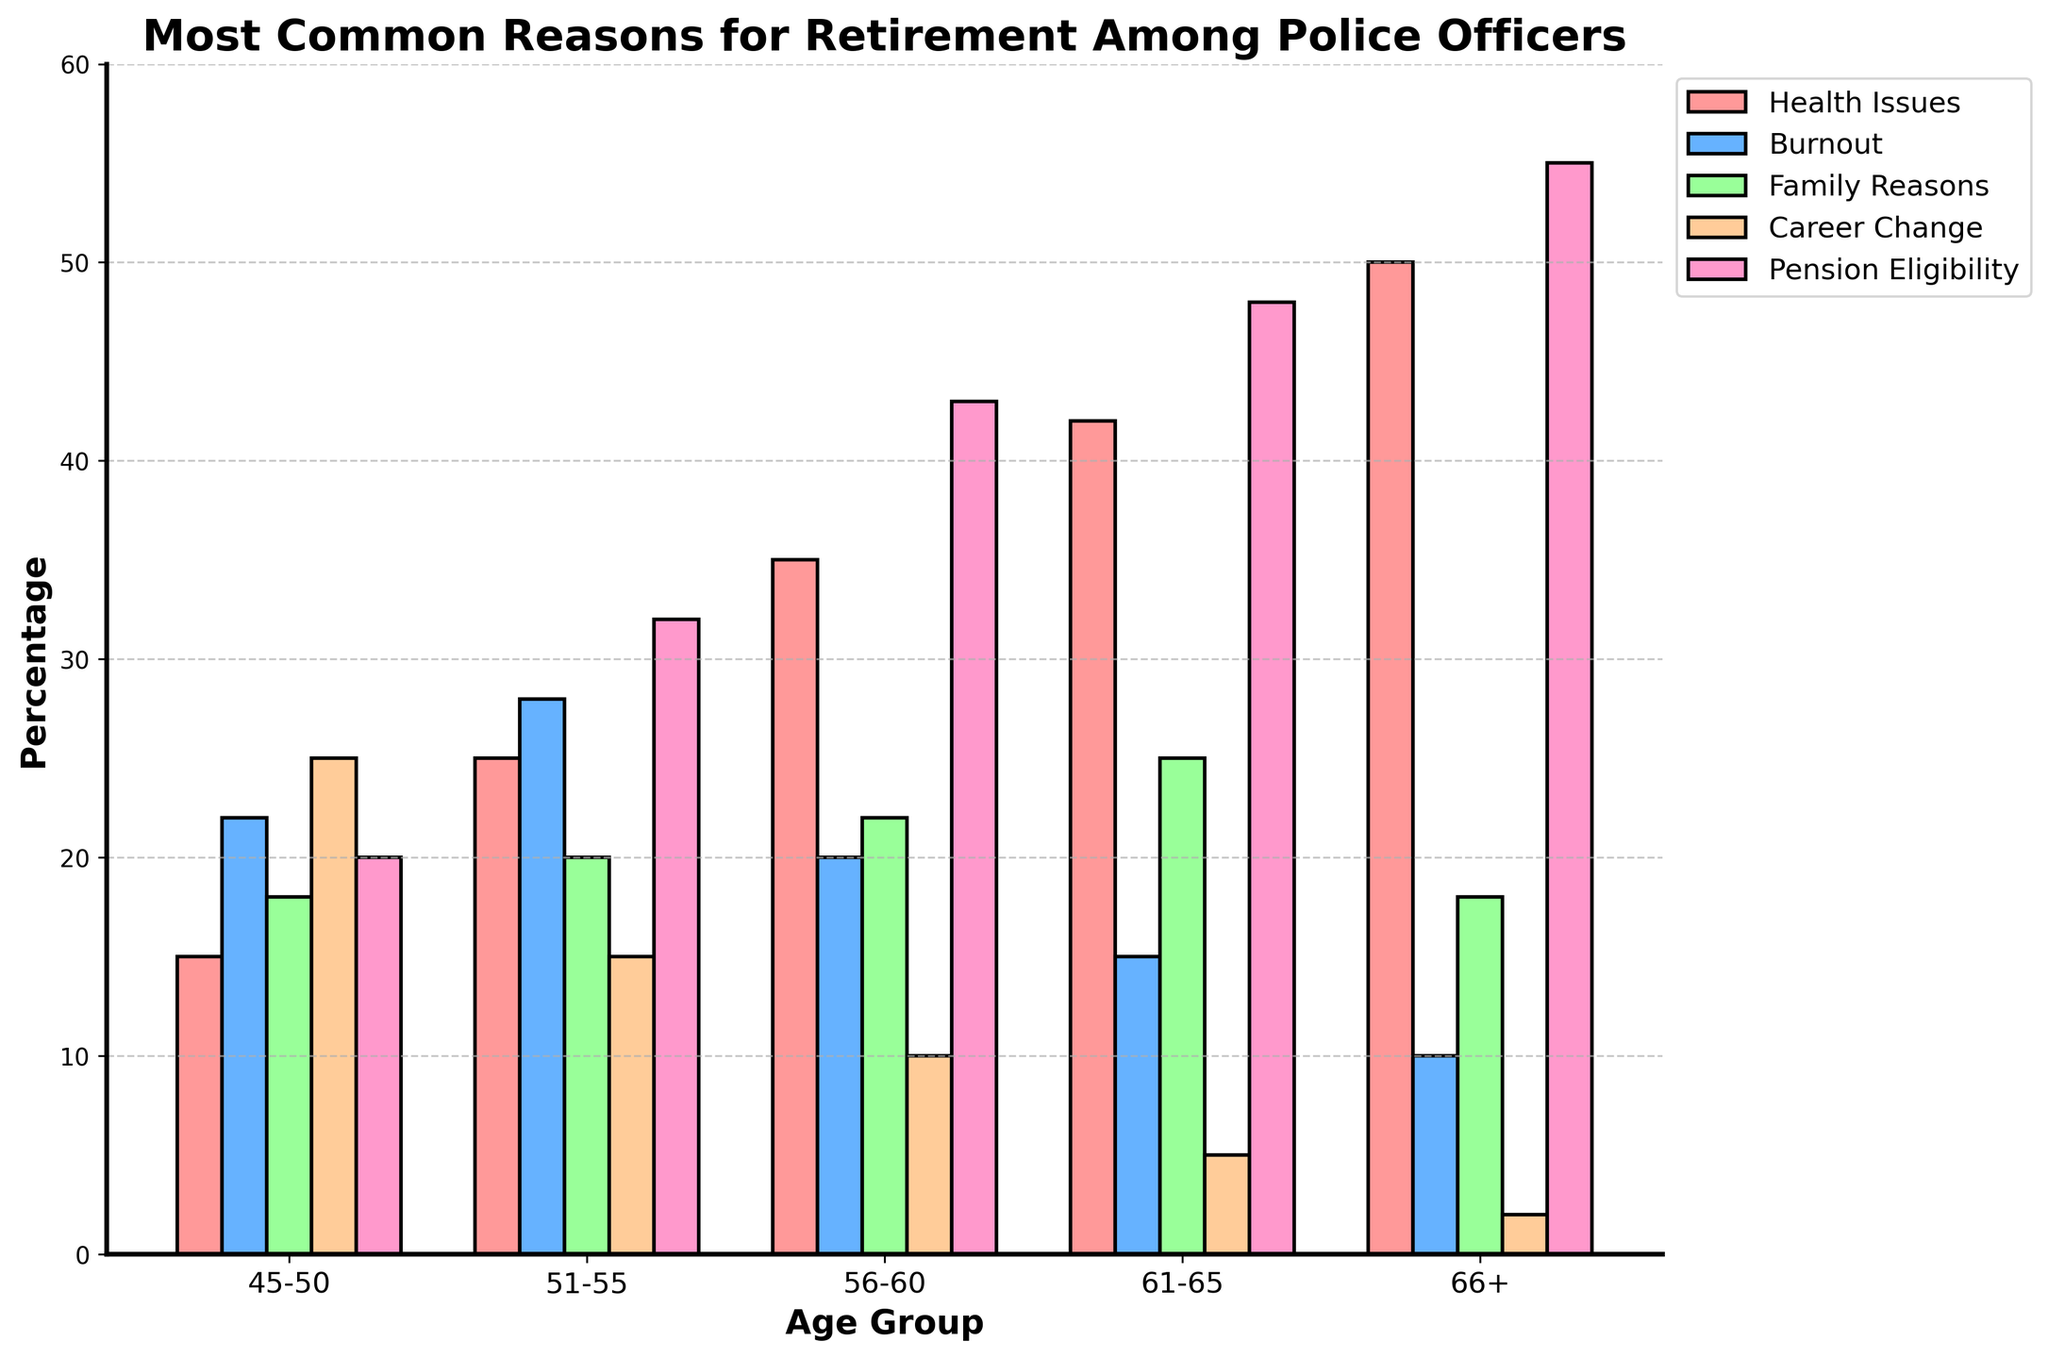What is the most common reason for retirement among officers aged 66+? The bar for 'Pension Eligibility' in the 66+ age group is the tallest compared to other reasons, indicating it's the most common reason.
Answer: Pension Eligibility Which age group has the highest percentage of officers retiring due to health issues? By comparing the heights of the 'Health Issues' bars across all age groups, the age group 66+ has the highest bar for health issues.
Answer: 66+ How does the percentage of officers retiring due to burnout change as age increases? Notice the bar heights for 'Burnout' reason across the age groups. It decreases from 22 (45-50) to 10 (66+), showing a downward trend.
Answer: Decreases Calculate the average percentage of officers retiring for family reasons across all age groups. Sum the values for 'Family Reasons' (18 + 20 + 22 + 25 + 18), which equals 103. Then, divide by the number of age groups, which is 5. The average is 103/5.
Answer: 20.6 Which age group retires the least due to career change? The bar for 'Career Change' in the age group 66+ is the shortest compared to all other age groups, indicating it's the least.
Answer: 66+ Is there any age group where 'Pension Eligibility' is not the most common reason for retirement? By examining the tallest bars (Pension Eligibility) in each age group, pension eligibility is the most common reason across all age groups as they are consistently the tallest.
Answer: No What is the difference between the percentage of officers retiring due to health issues and career change in the 51-55 age group? Subtract the 'Career Change' bar value (15) from the 'Health Issues' bar value (25) for the 51-55 age group. The difference is 25 - 15.
Answer: 10 Compare the percentages of officers aged 45-50 retiring due to family reasons and career change. Which is higher? The heights of the bars for 'Family Reasons' and 'Career Change' in the 45-50 age group show that career change (25) is higher than family reasons (18).
Answer: Career change Identify the age group with the lowest percentage of officers retiring due to burnout and provide that percentage. The 'Burnout' bar for the 66+ age group is the shortest across all age groups for burnout reasons, with a value of 10.
Answer: 66+, 10 Determine if the trend for officers retiring due to pension eligibility increases or decreases with age. Assess the bar heights for 'Pension Eligibility' in each age group; it increases from 20 (45-50) to 55 (66+), indicating an increasing trend.
Answer: Increases 